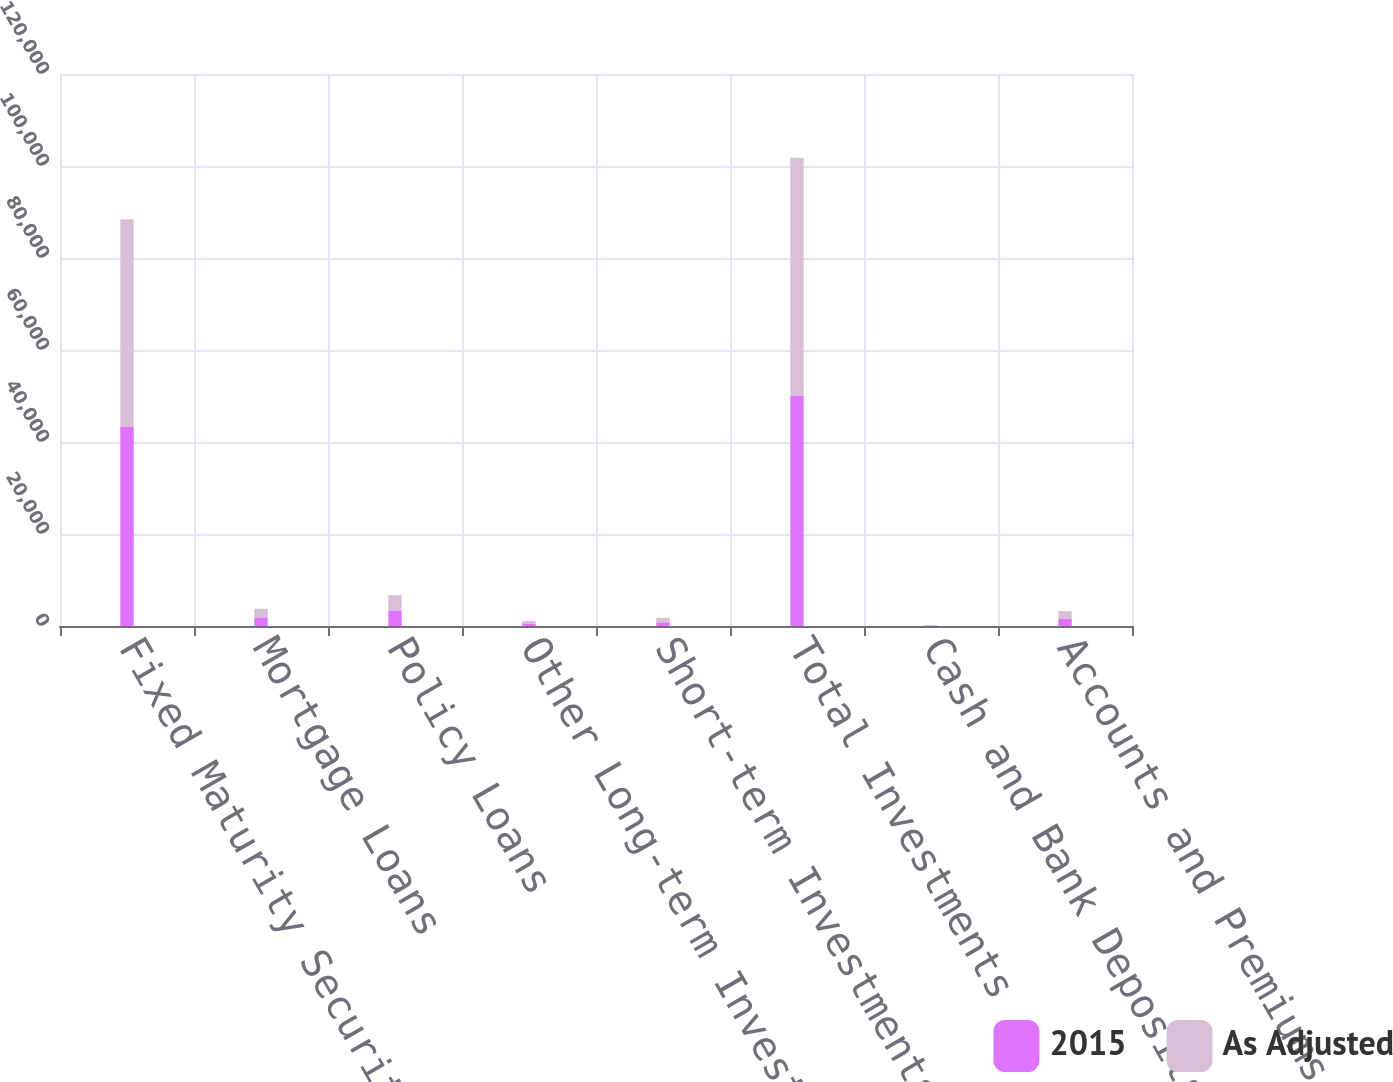Convert chart. <chart><loc_0><loc_0><loc_500><loc_500><stacked_bar_chart><ecel><fcel>Fixed Maturity Securities - at<fcel>Mortgage Loans<fcel>Policy Loans<fcel>Other Long-term Investments<fcel>Short-term Investments<fcel>Total Investments<fcel>Cash and Bank Deposits<fcel>Accounts and Premiums<nl><fcel>2015<fcel>43354.4<fcel>1883.6<fcel>3395.4<fcel>583<fcel>807.3<fcel>50023.7<fcel>112.9<fcel>1598.4<nl><fcel>As Adjusted<fcel>45064.9<fcel>1856.6<fcel>3306.6<fcel>545<fcel>974.3<fcel>51747.4<fcel>102.5<fcel>1634.7<nl></chart> 